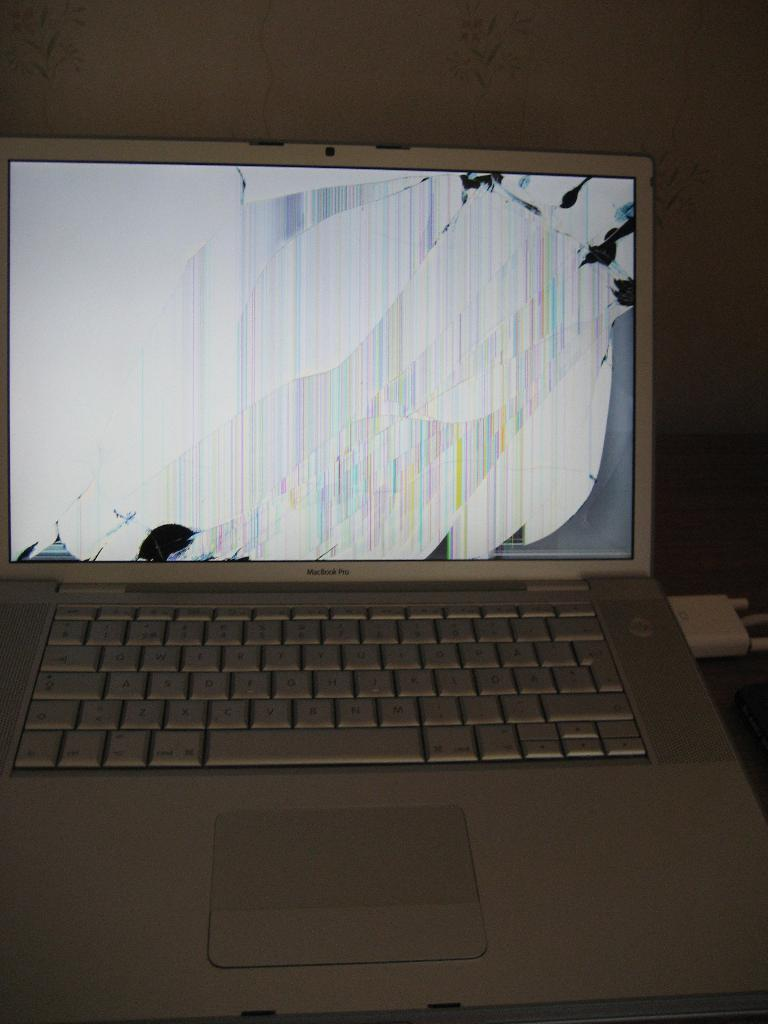<image>
Provide a brief description of the given image. A macbook pro that has a broken screen. 